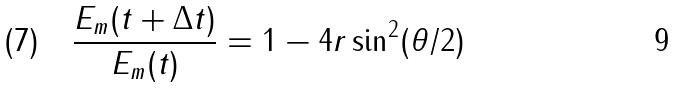Convert formula to latex. <formula><loc_0><loc_0><loc_500><loc_500>( 7 ) \quad { \frac { E _ { m } ( t + \Delta t ) } { E _ { m } ( t ) } } = 1 - 4 r \sin ^ { 2 } ( \theta / 2 )</formula> 